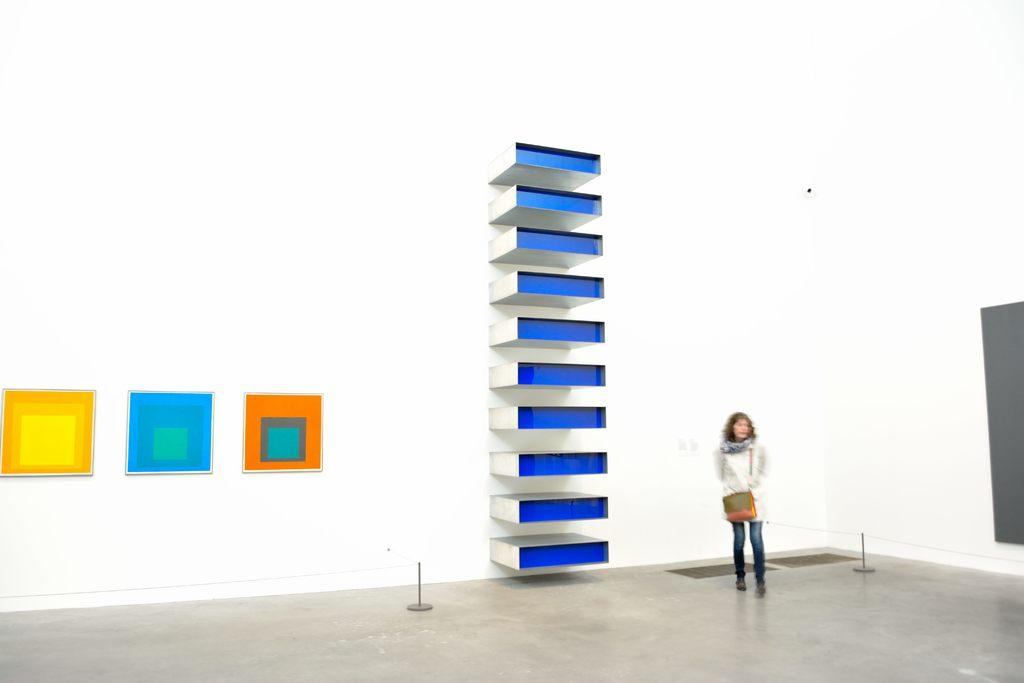Who is present in the image? There is a lady standing in the image. What is the lady standing on? The lady is standing on a floor. What can be seen in the background of the image? There is a wall in the background of the image. What objects are present in the image besides the lady? There are blocks in the image. What type of jam is being served on the plate in the image? There is no plate or jam present in the image; it only features a lady standing on a floor with blocks and a wall in the background. 